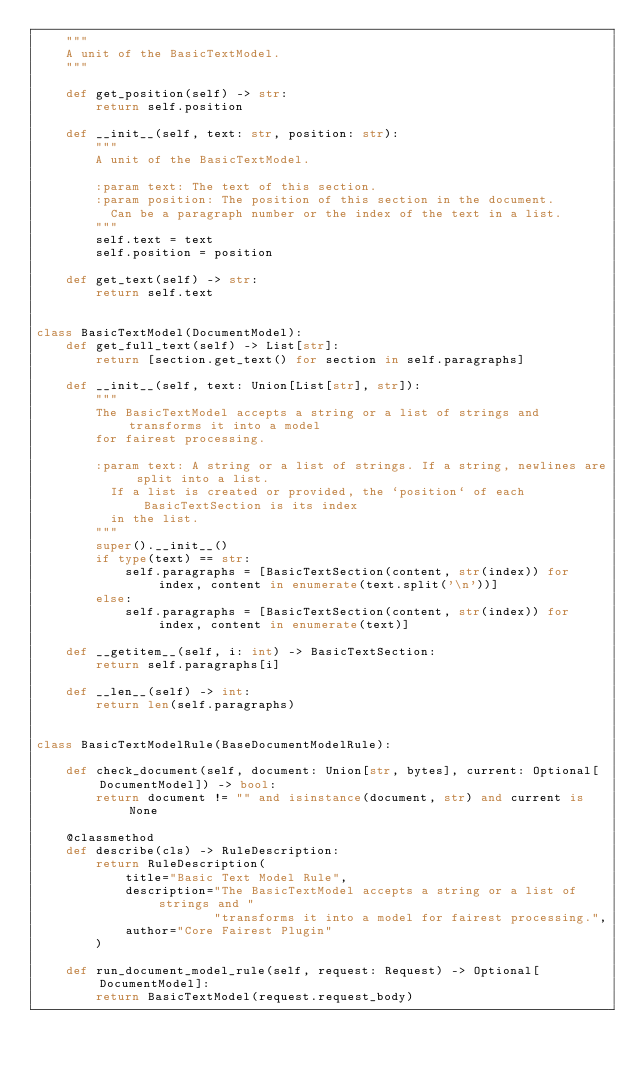Convert code to text. <code><loc_0><loc_0><loc_500><loc_500><_Python_>    """
    A unit of the BasicTextModel.
    """

    def get_position(self) -> str:
        return self.position

    def __init__(self, text: str, position: str):
        """
        A unit of the BasicTextModel.

        :param text: The text of this section.
        :param position: The position of this section in the document.
          Can be a paragraph number or the index of the text in a list.
        """
        self.text = text
        self.position = position

    def get_text(self) -> str:
        return self.text


class BasicTextModel(DocumentModel):
    def get_full_text(self) -> List[str]:
        return [section.get_text() for section in self.paragraphs]

    def __init__(self, text: Union[List[str], str]):
        """
        The BasicTextModel accepts a string or a list of strings and transforms it into a model
        for fairest processing.

        :param text: A string or a list of strings. If a string, newlines are split into a list.
          If a list is created or provided, the `position` of each BasicTextSection is its index
          in the list.
        """
        super().__init__()
        if type(text) == str:
            self.paragraphs = [BasicTextSection(content, str(index)) for index, content in enumerate(text.split('\n'))]
        else:
            self.paragraphs = [BasicTextSection(content, str(index)) for index, content in enumerate(text)]

    def __getitem__(self, i: int) -> BasicTextSection:
        return self.paragraphs[i]

    def __len__(self) -> int:
        return len(self.paragraphs)


class BasicTextModelRule(BaseDocumentModelRule):

    def check_document(self, document: Union[str, bytes], current: Optional[DocumentModel]) -> bool:
        return document != "" and isinstance(document, str) and current is None

    @classmethod
    def describe(cls) -> RuleDescription:
        return RuleDescription(
            title="Basic Text Model Rule",
            description="The BasicTextModel accepts a string or a list of strings and "
                        "transforms it into a model for fairest processing.",
            author="Core Fairest Plugin"
        )

    def run_document_model_rule(self, request: Request) -> Optional[DocumentModel]:
        return BasicTextModel(request.request_body)
</code> 